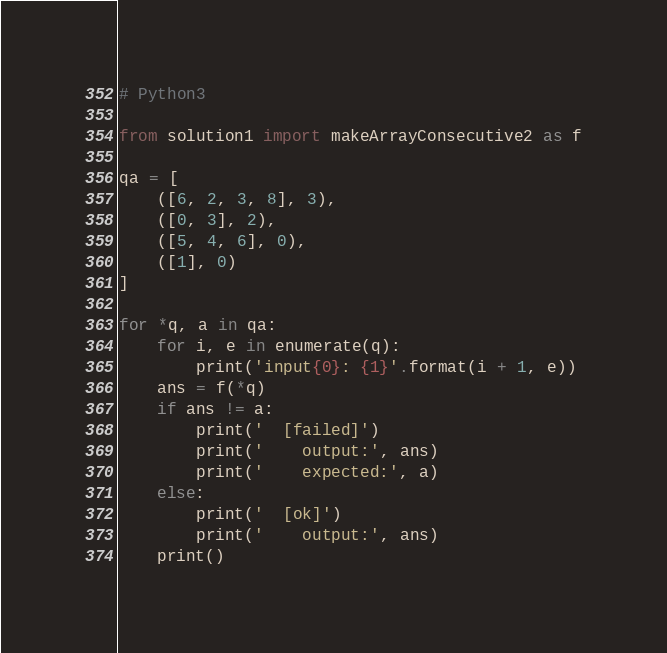Convert code to text. <code><loc_0><loc_0><loc_500><loc_500><_Python_># Python3

from solution1 import makeArrayConsecutive2 as f

qa = [
    ([6, 2, 3, 8], 3),
    ([0, 3], 2),
    ([5, 4, 6], 0),
    ([1], 0)
]

for *q, a in qa:
    for i, e in enumerate(q):
        print('input{0}: {1}'.format(i + 1, e))
    ans = f(*q)
    if ans != a:
        print('  [failed]')
        print('    output:', ans)
        print('    expected:', a)
    else:
        print('  [ok]')
        print('    output:', ans)
    print()
</code> 